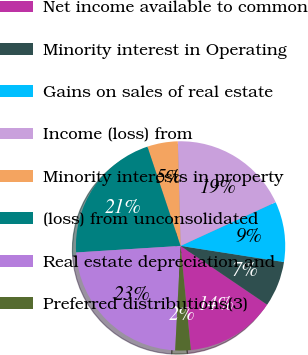<chart> <loc_0><loc_0><loc_500><loc_500><pie_chart><fcel>Net income available to common<fcel>Minority interest in Operating<fcel>Gains on sales of real estate<fcel>Income (loss) from<fcel>Minority interests in property<fcel>(loss) from unconsolidated<fcel>Real estate depreciation and<fcel>Preferred distributions(3)<nl><fcel>13.94%<fcel>7.02%<fcel>9.33%<fcel>18.56%<fcel>4.71%<fcel>20.87%<fcel>23.18%<fcel>2.4%<nl></chart> 